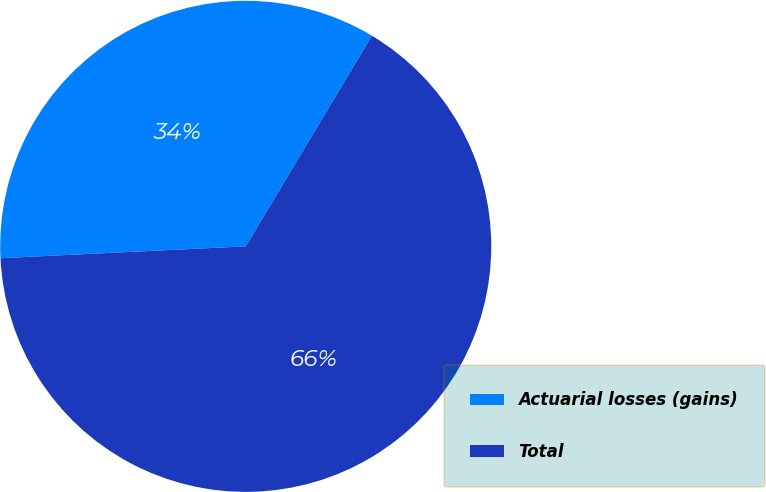<chart> <loc_0><loc_0><loc_500><loc_500><pie_chart><fcel>Actuarial losses (gains)<fcel>Total<nl><fcel>34.36%<fcel>65.64%<nl></chart> 